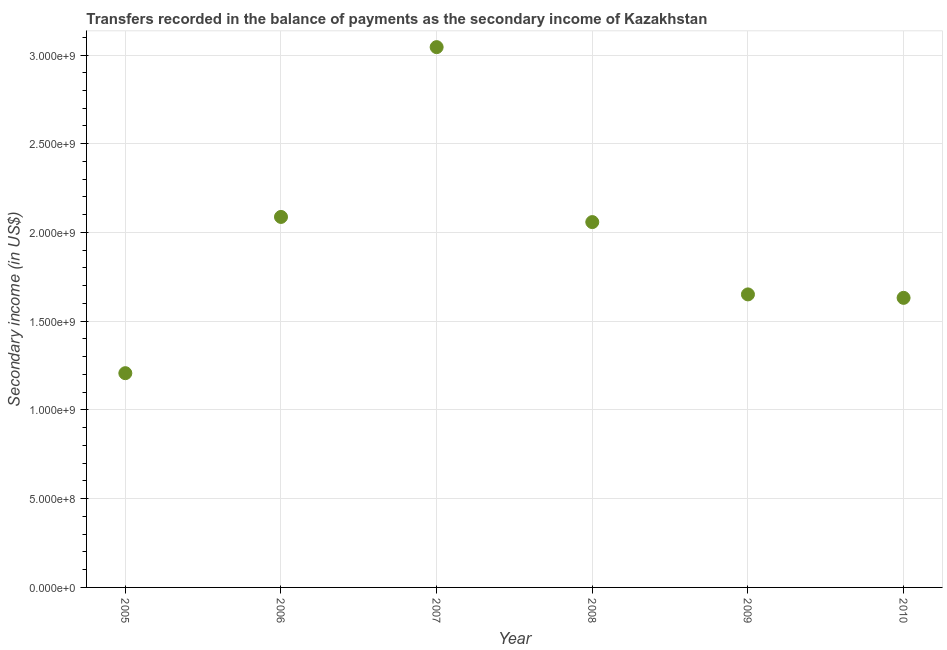What is the amount of secondary income in 2010?
Your answer should be very brief. 1.63e+09. Across all years, what is the maximum amount of secondary income?
Ensure brevity in your answer.  3.04e+09. Across all years, what is the minimum amount of secondary income?
Provide a short and direct response. 1.21e+09. In which year was the amount of secondary income maximum?
Your response must be concise. 2007. What is the sum of the amount of secondary income?
Your answer should be very brief. 1.17e+1. What is the difference between the amount of secondary income in 2007 and 2008?
Your response must be concise. 9.86e+08. What is the average amount of secondary income per year?
Give a very brief answer. 1.95e+09. What is the median amount of secondary income?
Provide a short and direct response. 1.85e+09. In how many years, is the amount of secondary income greater than 2200000000 US$?
Your response must be concise. 1. Do a majority of the years between 2005 and 2006 (inclusive) have amount of secondary income greater than 1200000000 US$?
Your answer should be compact. Yes. What is the ratio of the amount of secondary income in 2006 to that in 2010?
Keep it short and to the point. 1.28. What is the difference between the highest and the second highest amount of secondary income?
Your response must be concise. 9.57e+08. What is the difference between the highest and the lowest amount of secondary income?
Your response must be concise. 1.84e+09. Does the amount of secondary income monotonically increase over the years?
Give a very brief answer. No. How many dotlines are there?
Provide a succinct answer. 1. How many years are there in the graph?
Your answer should be compact. 6. Does the graph contain any zero values?
Keep it short and to the point. No. Does the graph contain grids?
Offer a terse response. Yes. What is the title of the graph?
Your answer should be very brief. Transfers recorded in the balance of payments as the secondary income of Kazakhstan. What is the label or title of the X-axis?
Your answer should be very brief. Year. What is the label or title of the Y-axis?
Offer a terse response. Secondary income (in US$). What is the Secondary income (in US$) in 2005?
Ensure brevity in your answer.  1.21e+09. What is the Secondary income (in US$) in 2006?
Provide a short and direct response. 2.09e+09. What is the Secondary income (in US$) in 2007?
Your answer should be very brief. 3.04e+09. What is the Secondary income (in US$) in 2008?
Give a very brief answer. 2.06e+09. What is the Secondary income (in US$) in 2009?
Your answer should be very brief. 1.65e+09. What is the Secondary income (in US$) in 2010?
Your answer should be very brief. 1.63e+09. What is the difference between the Secondary income (in US$) in 2005 and 2006?
Give a very brief answer. -8.80e+08. What is the difference between the Secondary income (in US$) in 2005 and 2007?
Offer a terse response. -1.84e+09. What is the difference between the Secondary income (in US$) in 2005 and 2008?
Your answer should be very brief. -8.51e+08. What is the difference between the Secondary income (in US$) in 2005 and 2009?
Provide a succinct answer. -4.44e+08. What is the difference between the Secondary income (in US$) in 2005 and 2010?
Make the answer very short. -4.24e+08. What is the difference between the Secondary income (in US$) in 2006 and 2007?
Make the answer very short. -9.57e+08. What is the difference between the Secondary income (in US$) in 2006 and 2008?
Make the answer very short. 2.91e+07. What is the difference between the Secondary income (in US$) in 2006 and 2009?
Your answer should be very brief. 4.37e+08. What is the difference between the Secondary income (in US$) in 2006 and 2010?
Provide a short and direct response. 4.56e+08. What is the difference between the Secondary income (in US$) in 2007 and 2008?
Your answer should be very brief. 9.86e+08. What is the difference between the Secondary income (in US$) in 2007 and 2009?
Make the answer very short. 1.39e+09. What is the difference between the Secondary income (in US$) in 2007 and 2010?
Provide a short and direct response. 1.41e+09. What is the difference between the Secondary income (in US$) in 2008 and 2009?
Provide a short and direct response. 4.07e+08. What is the difference between the Secondary income (in US$) in 2008 and 2010?
Offer a very short reply. 4.27e+08. What is the difference between the Secondary income (in US$) in 2009 and 2010?
Your response must be concise. 1.94e+07. What is the ratio of the Secondary income (in US$) in 2005 to that in 2006?
Offer a terse response. 0.58. What is the ratio of the Secondary income (in US$) in 2005 to that in 2007?
Your response must be concise. 0.4. What is the ratio of the Secondary income (in US$) in 2005 to that in 2008?
Give a very brief answer. 0.59. What is the ratio of the Secondary income (in US$) in 2005 to that in 2009?
Your answer should be compact. 0.73. What is the ratio of the Secondary income (in US$) in 2005 to that in 2010?
Your answer should be very brief. 0.74. What is the ratio of the Secondary income (in US$) in 2006 to that in 2007?
Offer a very short reply. 0.69. What is the ratio of the Secondary income (in US$) in 2006 to that in 2009?
Your answer should be very brief. 1.26. What is the ratio of the Secondary income (in US$) in 2006 to that in 2010?
Your answer should be very brief. 1.28. What is the ratio of the Secondary income (in US$) in 2007 to that in 2008?
Ensure brevity in your answer.  1.48. What is the ratio of the Secondary income (in US$) in 2007 to that in 2009?
Your answer should be compact. 1.84. What is the ratio of the Secondary income (in US$) in 2007 to that in 2010?
Offer a very short reply. 1.87. What is the ratio of the Secondary income (in US$) in 2008 to that in 2009?
Offer a terse response. 1.25. What is the ratio of the Secondary income (in US$) in 2008 to that in 2010?
Your response must be concise. 1.26. What is the ratio of the Secondary income (in US$) in 2009 to that in 2010?
Offer a very short reply. 1.01. 